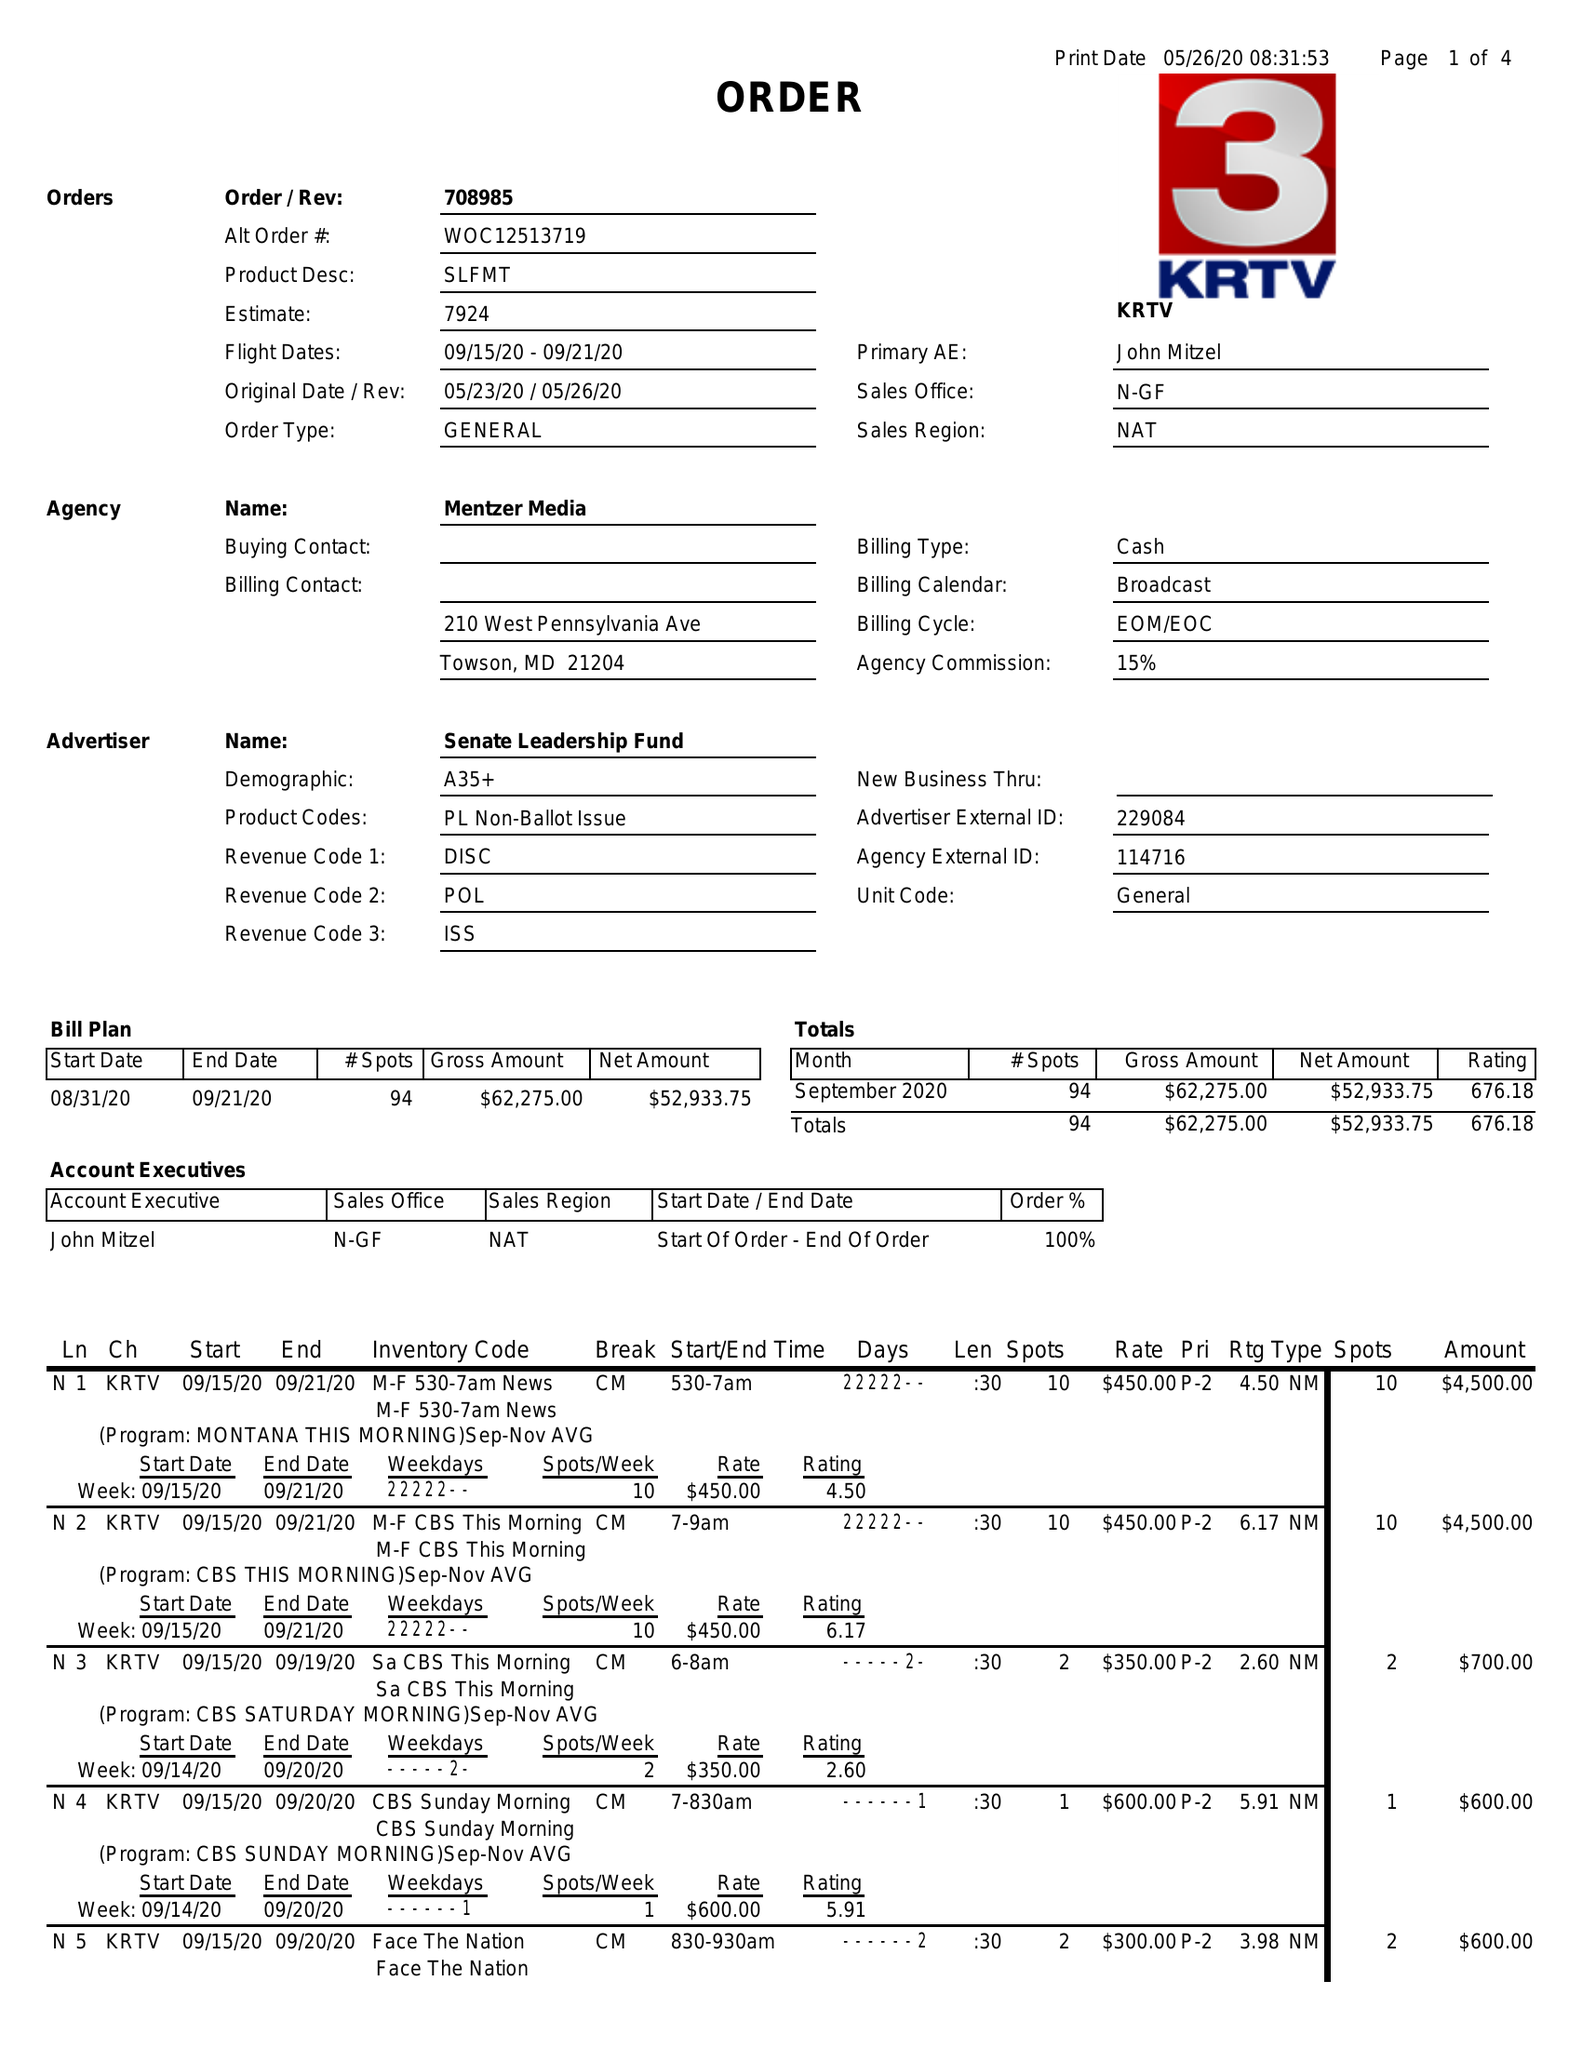What is the value for the contract_num?
Answer the question using a single word or phrase. 708985 